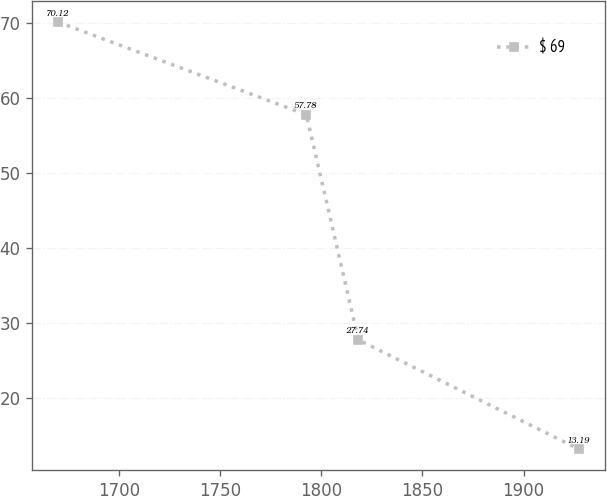Convert chart to OTSL. <chart><loc_0><loc_0><loc_500><loc_500><line_chart><ecel><fcel>$ 69<nl><fcel>1669.72<fcel>70.12<nl><fcel>1792.55<fcel>57.78<nl><fcel>1818.31<fcel>27.74<nl><fcel>1927.36<fcel>13.19<nl></chart> 